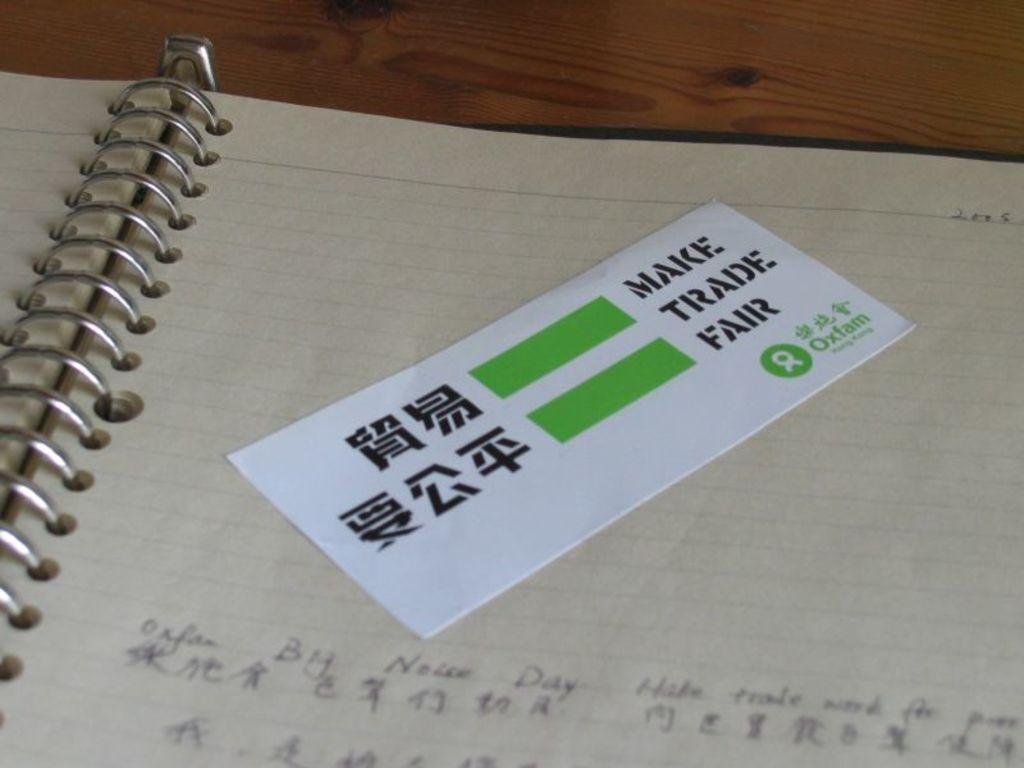<image>
Provide a brief description of the given image. A Make Trade Fair card is on a notebook. 